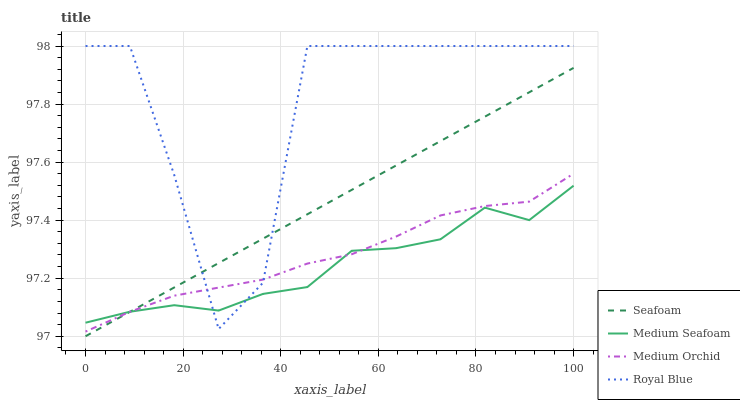Does Medium Seafoam have the minimum area under the curve?
Answer yes or no. Yes. Does Royal Blue have the maximum area under the curve?
Answer yes or no. Yes. Does Medium Orchid have the minimum area under the curve?
Answer yes or no. No. Does Medium Orchid have the maximum area under the curve?
Answer yes or no. No. Is Seafoam the smoothest?
Answer yes or no. Yes. Is Royal Blue the roughest?
Answer yes or no. Yes. Is Medium Orchid the smoothest?
Answer yes or no. No. Is Medium Orchid the roughest?
Answer yes or no. No. Does Seafoam have the lowest value?
Answer yes or no. Yes. Does Medium Orchid have the lowest value?
Answer yes or no. No. Does Royal Blue have the highest value?
Answer yes or no. Yes. Does Medium Orchid have the highest value?
Answer yes or no. No. Does Seafoam intersect Medium Orchid?
Answer yes or no. Yes. Is Seafoam less than Medium Orchid?
Answer yes or no. No. Is Seafoam greater than Medium Orchid?
Answer yes or no. No. 